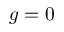Convert formula to latex. <formula><loc_0><loc_0><loc_500><loc_500>g = 0</formula> 